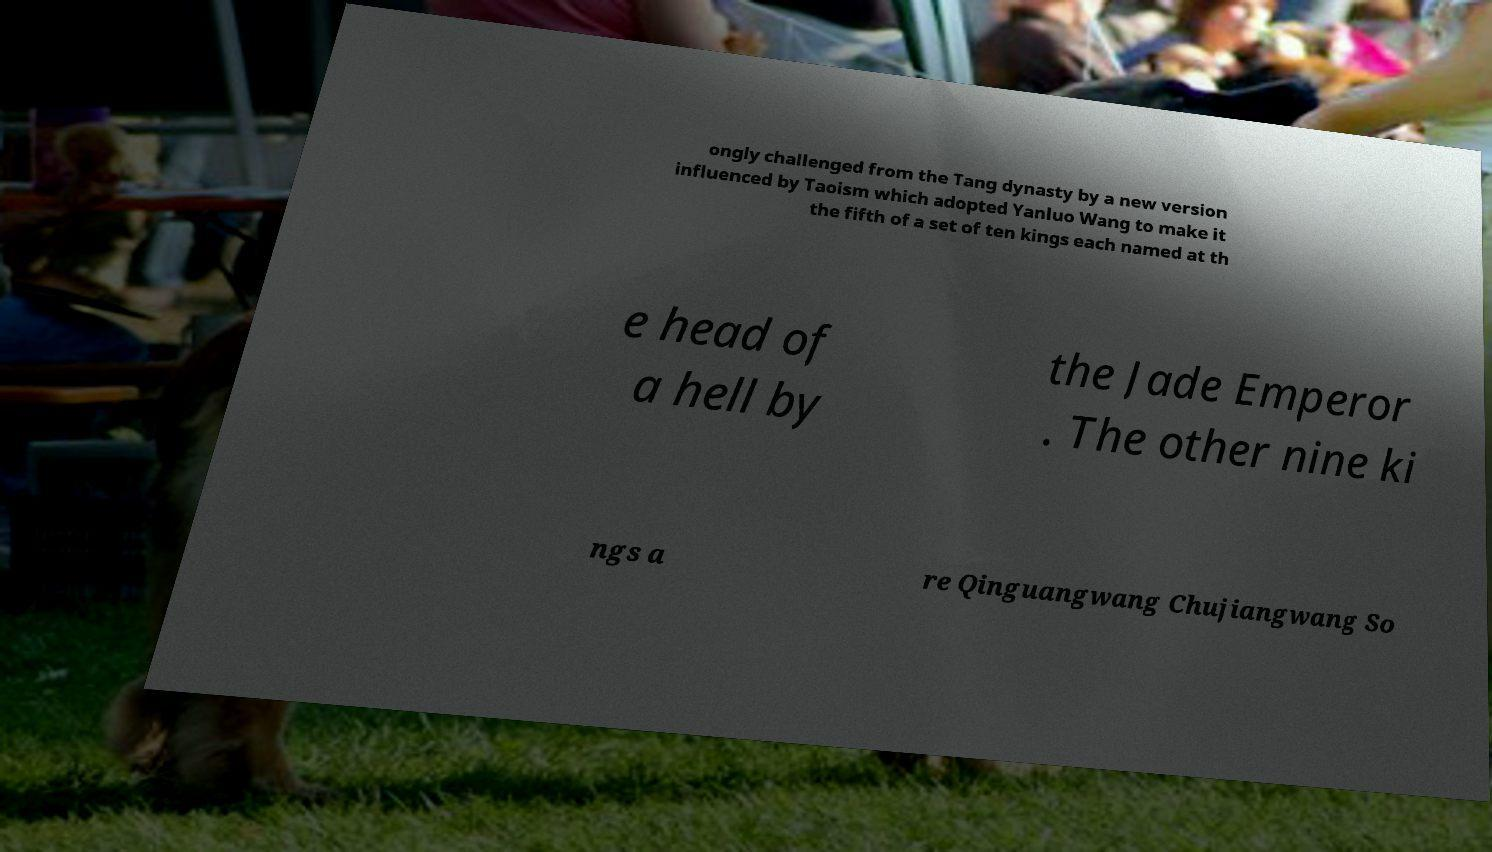Can you read and provide the text displayed in the image?This photo seems to have some interesting text. Can you extract and type it out for me? ongly challenged from the Tang dynasty by a new version influenced by Taoism which adopted Yanluo Wang to make it the fifth of a set of ten kings each named at th e head of a hell by the Jade Emperor . The other nine ki ngs a re Qinguangwang Chujiangwang So 